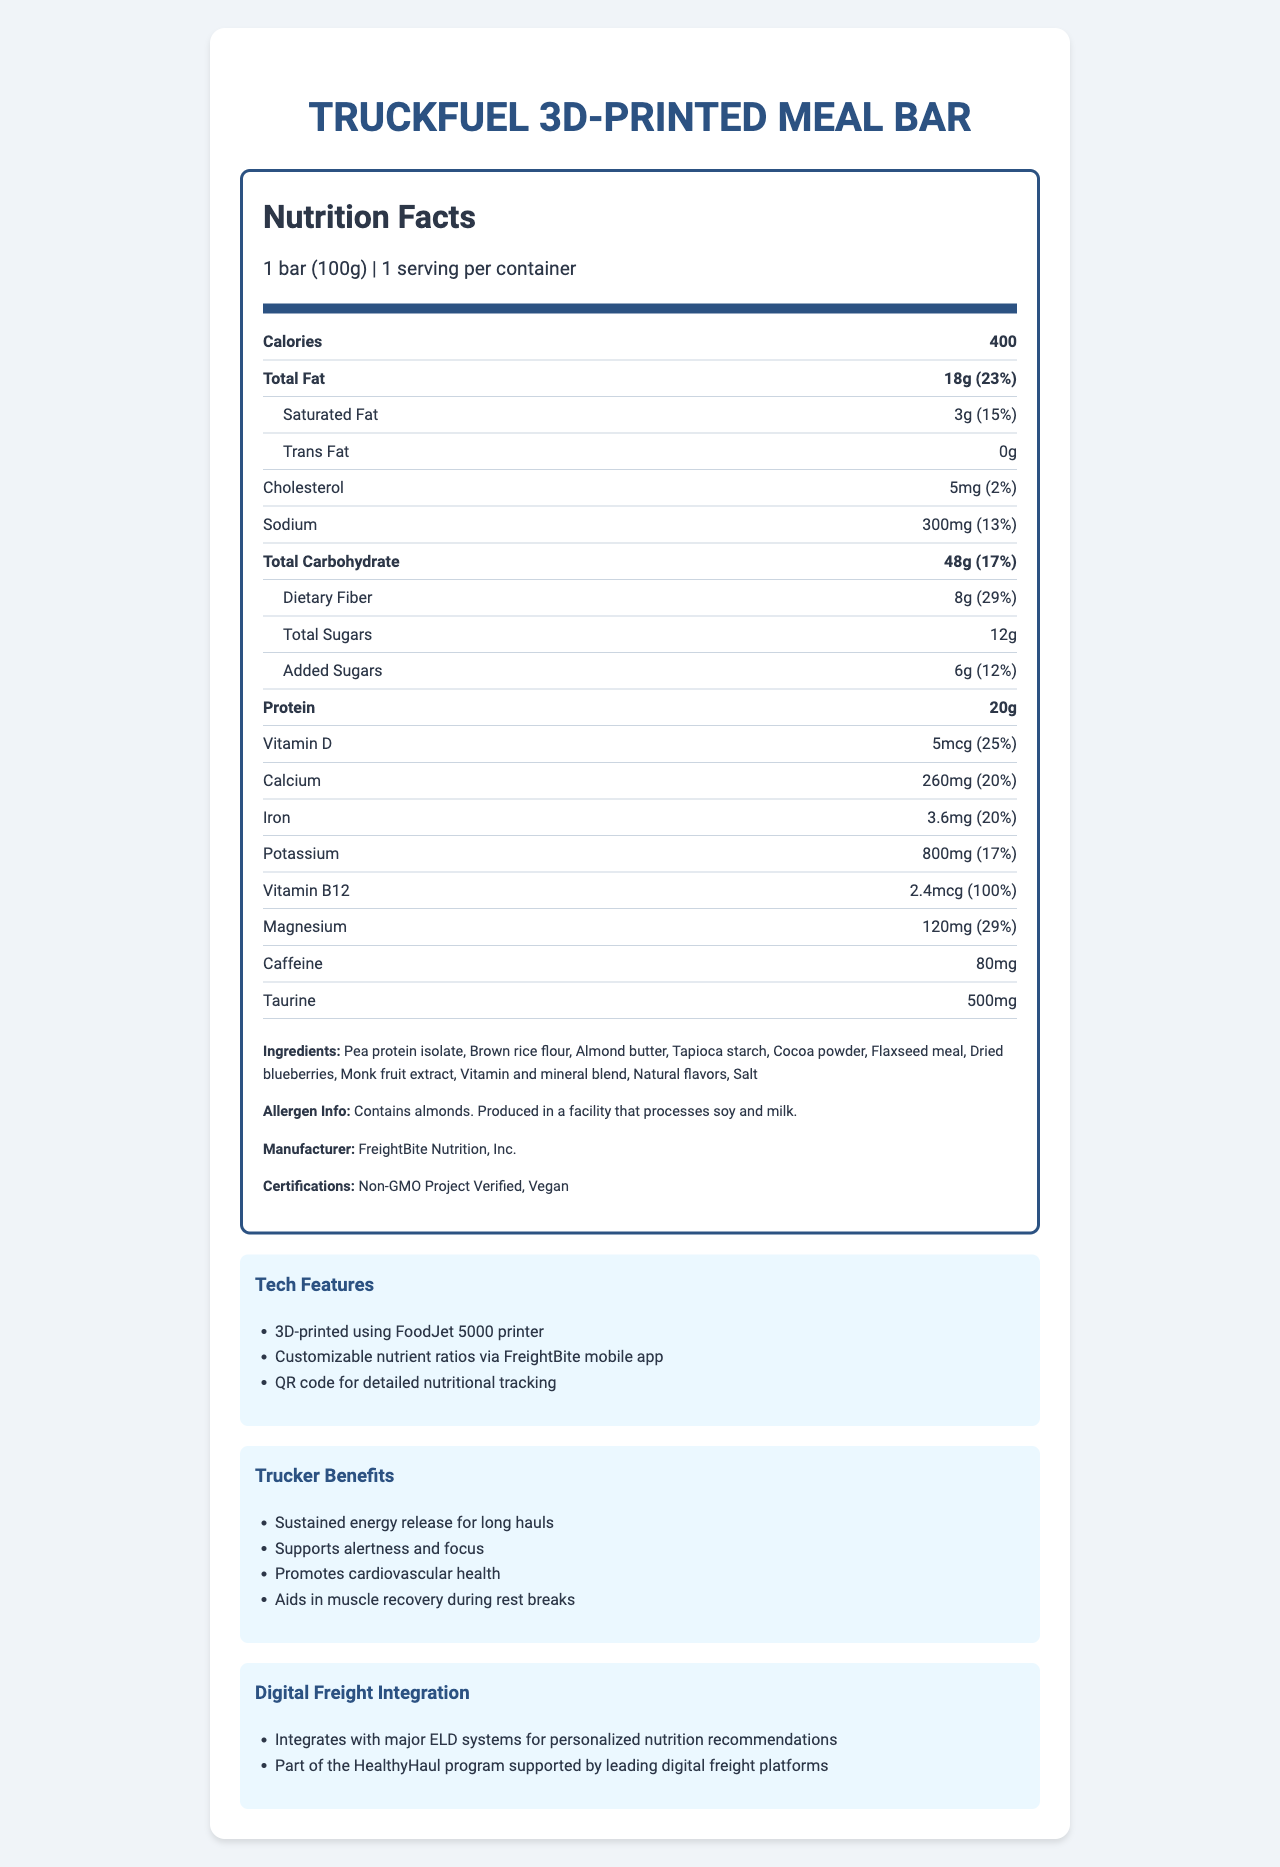what is the serving size of the TruckFuel 3D-Printed Meal Bar? The serving size is stated at the top of the Nutrition Facts section as "1 bar (100g)".
Answer: 1 bar (100g) How many calories does one bar contain? The calories are listed in a bold nutrient row as "Calories 400".
Answer: 400 What is the daily value percentage of total fat in the bar? The daily value percentage for total fat is listed as "23%" next to the total fat amount.
Answer: 23% What are the benefits for truckers consuming this meal bar? These benefits are listed under "Trucker Benefits".
Answer: Sustained energy release for long hauls, Supports alertness and focus, Promotes cardiovascular health, Aids in muscle recovery during rest breaks How much protein is in one bar? The amount of protein is listed in a bold nutrient row as "Protein 20g".
Answer: 20g What is the amount of dietary fiber in this meal bar and its daily value percentage? The dietary fiber amount is listed as "8g" and the daily value percentage as "29%" under the Total Carbohydrate section.
Answer: 8g (29%) What certifications does the TruckFuel 3D-Printed Meal Bar have? A. Organic B. Non-GMO Project Verified C. Vegan D. Gluten-Free The document lists "Non-GMO Project Verified" and "Vegan" under Certifications.
Answer: B. Non-GMO Project Verified and C. Vegan Which technological feature allows for customized nutrient ratios? A. FreightBite 3D-Printed B. FoodJet 5000 printer C. QR code D. FreightBite mobile app The ability to customize nutrient ratios via the FreightBite mobile app is listed under Tech Features.
Answer: D. FreightBite mobile app Does the bar contain any trans fat? The amount of trans fat is listed as "0g".
Answer: No Summarize the main idea of the document. The document describes the nutritional content, health benefits, and technological features of the TruckFuel 3D-Printed Meal Bar, tailored for long-haul truck drivers, and produced by FreightBite Nutrition, Inc.
Answer: The TruckFuel 3D-Printed Meal Bar is a nutritionally customized meal designed for long-haul truck drivers, offering health benefits such as sustained energy, focus, cardiovascular health, and muscle recovery. It is produced by FreightBite Nutrition, Inc., using advanced 3D-printing technology and integrates with digital freight systems for personalized recommendations. What percentage of Vitamin B12 does the bar provide according to its daily value? The daily value percentage for Vitamin B12 is listed as "100%".
Answer: 100% Can the caffeine content in the bar be determined visually? The amount of caffeine is listed as "80mg".
Answer: Yes, it is 80mg What ingredient is potentially allergenic in this meal bar? The allergen info states "Contains almonds".
Answer: Almonds Is there any information about the sugar source used in the bar? The document does not provide specific details about the sugar sources beyond "Total Sugars" and "Added Sugars".
Answer: Not enough information What additional functionalities does the bar provide that integrate with digital freight platforms? These functionalities are listed under Digital Freight Integration.
Answer: Integrates with major ELD systems for personalized nutrition recommendations, Part of the HealthyHaul program supported by leading digital freight platforms Which ingredient is not listed? A. Cocoa powder B. Honey C. Monk fruit extract Honey is not listed in the ingredients; only "Cocoa powder" and "Monk fruit extract" are listed.
Answer: B. Honey How much cholesterol is in the bar? The amount of cholesterol is listed as "5mg".
Answer: 5mg 